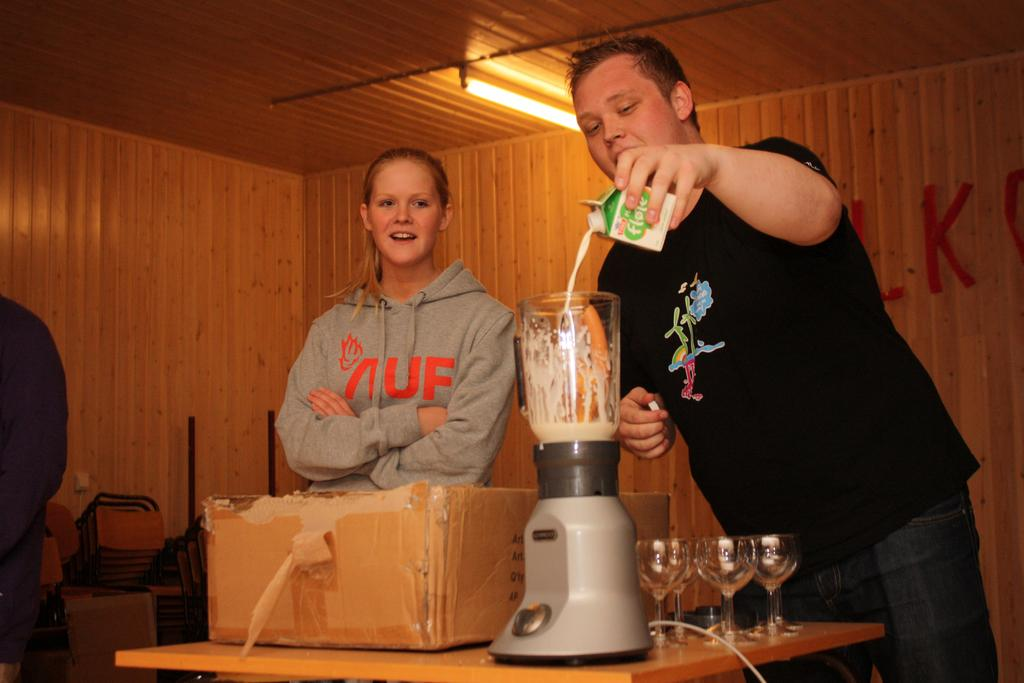<image>
Render a clear and concise summary of the photo. A man wearing black pours a container of Flote Milk into a blender 